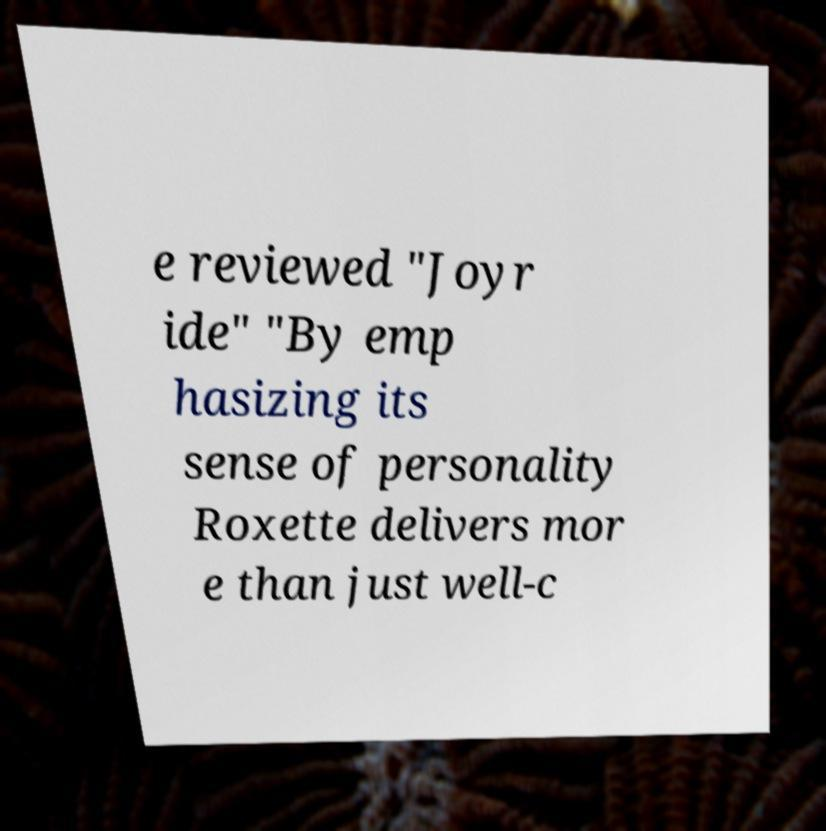Please read and relay the text visible in this image. What does it say? e reviewed "Joyr ide" "By emp hasizing its sense of personality Roxette delivers mor e than just well-c 